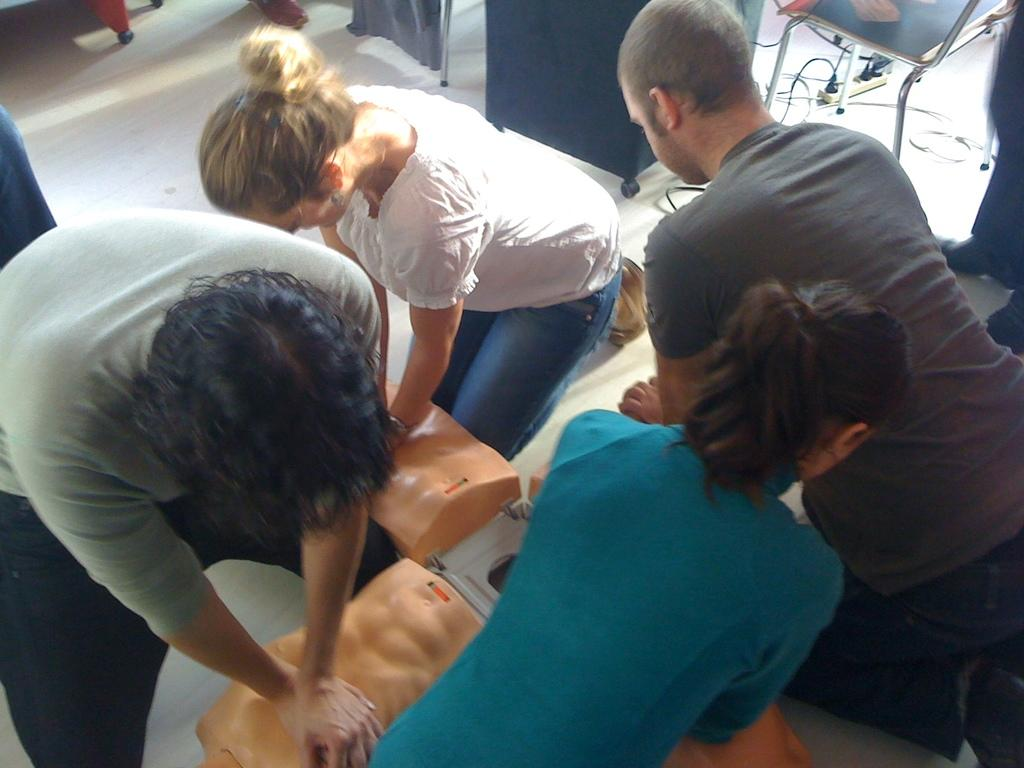How many people are present in the image? There are four people in the image. What are the people doing in the image? The people are sitting on their knees and pressing an artificial abdomen. What can be seen connected to the artificial abdomen? There are wires visible in the image. What is the purpose of the switchboard in the image? The switchboard is likely used to control the wires and the artificial abdomen. What type of furniture is present in the image? There are chairs in the image. What country is the airplane flying over in the image? There is no airplane present in the image, so it is not possible to determine the country it might be flying over. 